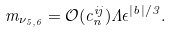<formula> <loc_0><loc_0><loc_500><loc_500>m _ { \nu _ { 5 , 6 } } = \mathcal { O } ( c _ { n } ^ { i j } ) \Lambda \epsilon ^ { | b | / 3 } .</formula> 